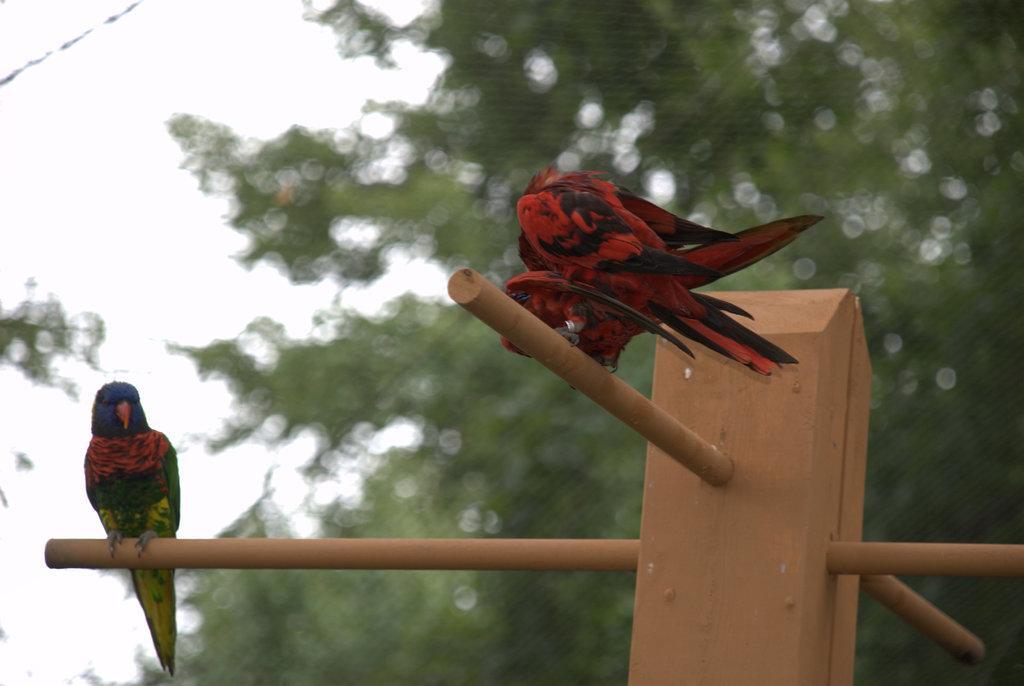Describe this image in one or two sentences. In this image I can see two parrots are sitting on a rod. In the background I can see trees and the sky. This image is taken during a day. 